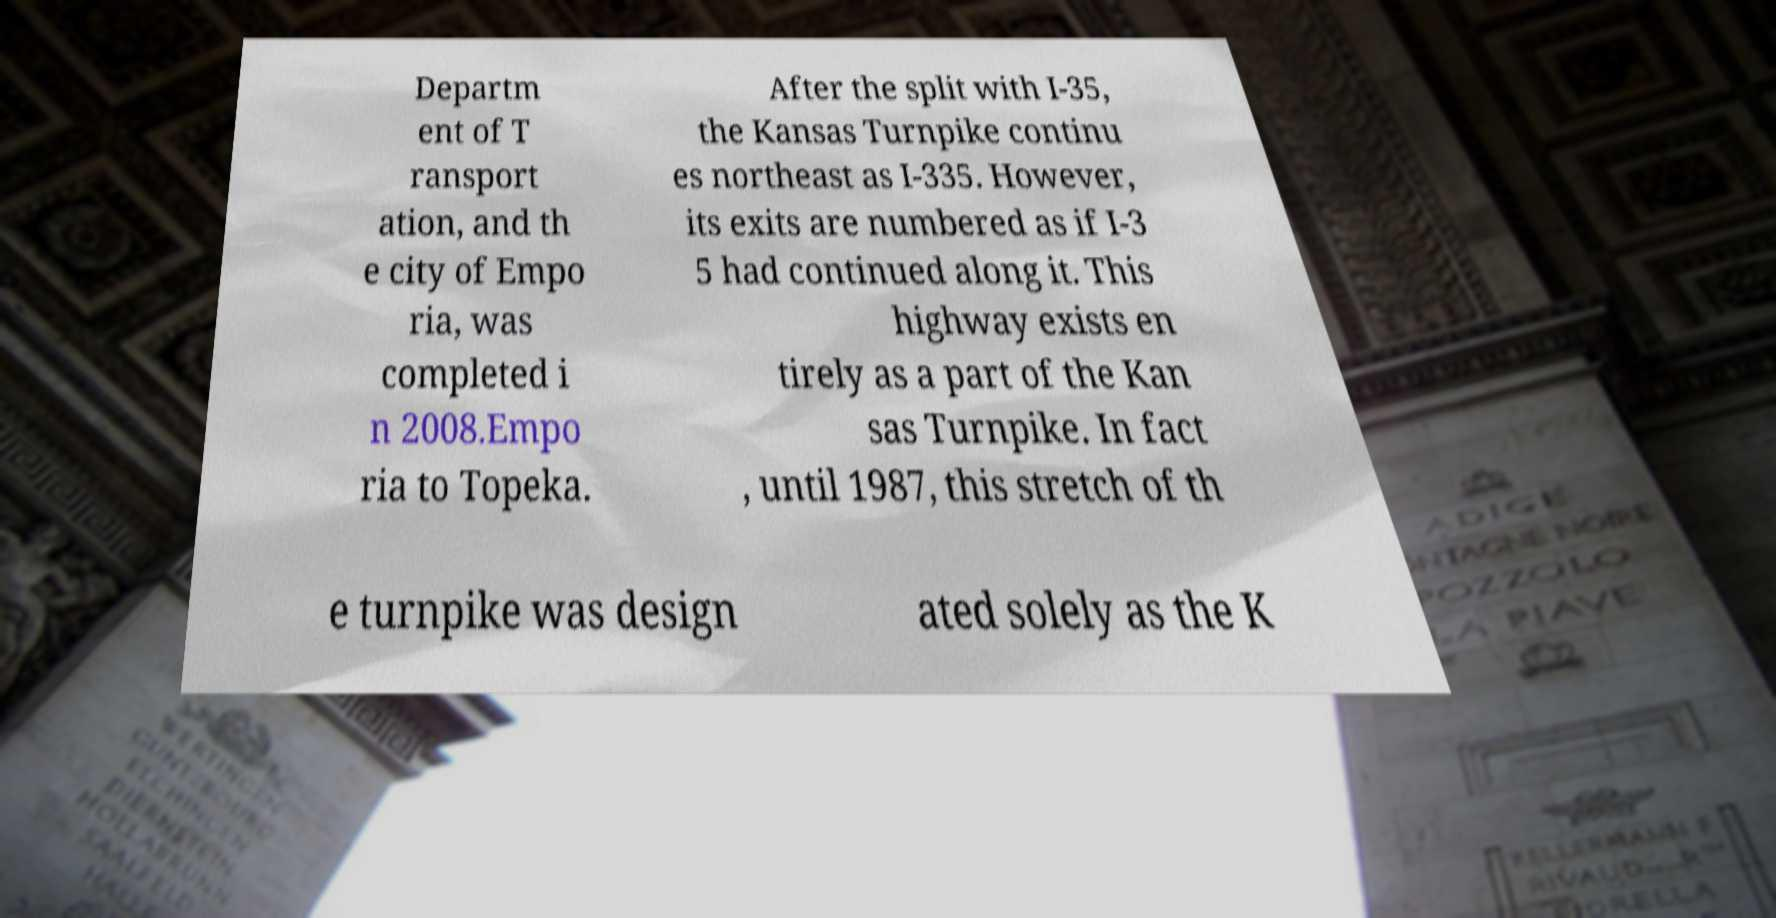For documentation purposes, I need the text within this image transcribed. Could you provide that? Departm ent of T ransport ation, and th e city of Empo ria, was completed i n 2008.Empo ria to Topeka. After the split with I-35, the Kansas Turnpike continu es northeast as I-335. However, its exits are numbered as if I-3 5 had continued along it. This highway exists en tirely as a part of the Kan sas Turnpike. In fact , until 1987, this stretch of th e turnpike was design ated solely as the K 